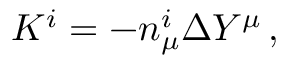Convert formula to latex. <formula><loc_0><loc_0><loc_500><loc_500>K ^ { i } = - n _ { \mu } ^ { i } \Delta Y ^ { \mu } \, ,</formula> 